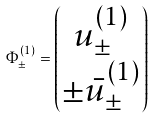Convert formula to latex. <formula><loc_0><loc_0><loc_500><loc_500>\Phi ^ { ( 1 ) } _ { \pm } = \begin{pmatrix} u ^ { ( 1 ) } _ { \pm } \\ \pm \bar { u } ^ { ( 1 ) } _ { \pm } \end{pmatrix}</formula> 